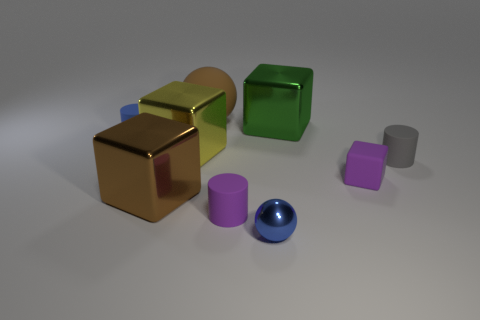What material is the big cube that is the same color as the big matte ball?
Your answer should be compact. Metal. The small thing that is the same shape as the large brown rubber object is what color?
Provide a succinct answer. Blue. Do the brown cube and the cylinder that is left of the big brown block have the same material?
Your answer should be very brief. No. The big rubber ball is what color?
Offer a terse response. Brown. There is a big object that is behind the metal block that is right of the tiny cylinder that is in front of the tiny matte cube; what is its color?
Your response must be concise. Brown. There is a large green metallic thing; is its shape the same as the blue thing that is behind the purple rubber cylinder?
Provide a succinct answer. No. What is the color of the tiny object that is behind the tiny shiny object and in front of the purple matte cube?
Give a very brief answer. Purple. Are there any big yellow objects that have the same shape as the tiny shiny thing?
Your answer should be compact. No. Is the color of the tiny block the same as the small metal ball?
Provide a succinct answer. No. There is a cylinder that is behind the tiny gray matte object; are there any small blue rubber objects on the left side of it?
Offer a terse response. No. 